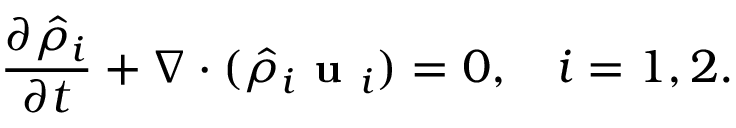Convert formula to latex. <formula><loc_0><loc_0><loc_500><loc_500>\frac { \partial \hat { \rho } _ { i } } { \partial t } + \nabla \cdot ( \hat { \rho } _ { i } u _ { i } ) = 0 , \quad i = 1 , 2 .</formula> 